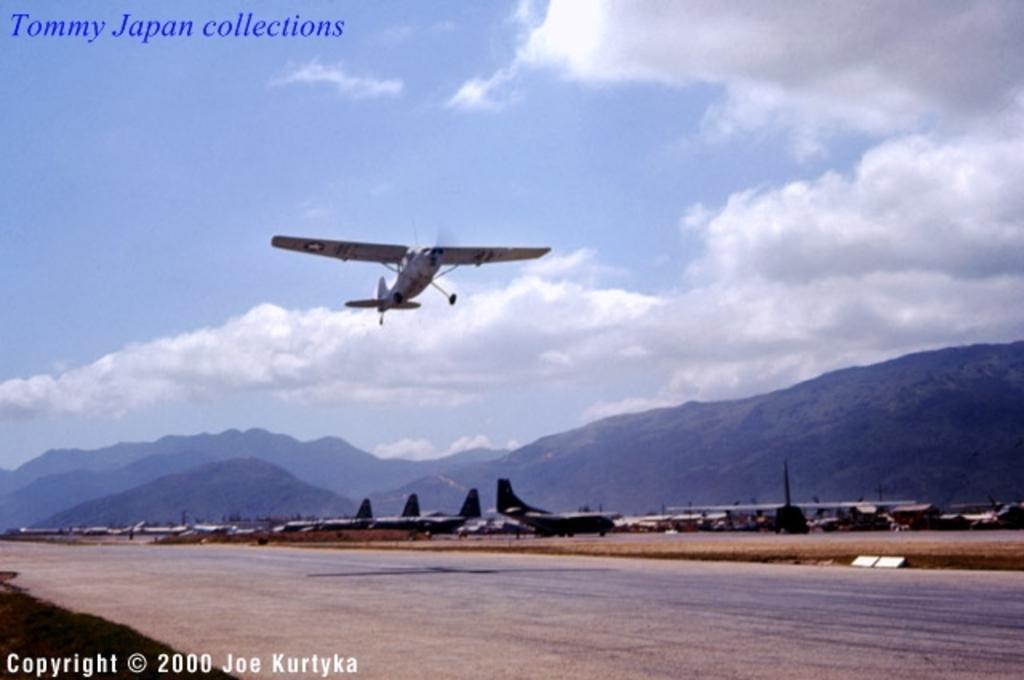Could you give a brief overview of what you see in this image? In the picture I can see airplanes among them one aeroplane is flying in the air. In the background I can see the sky and mountains. I can also see watermarks on the image. 